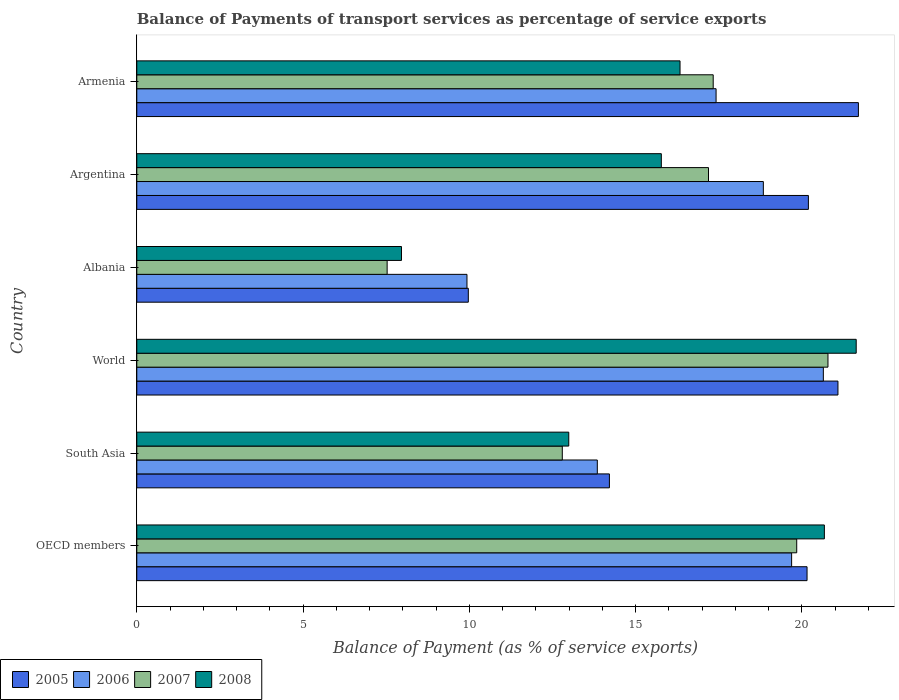How many different coloured bars are there?
Offer a very short reply. 4. How many groups of bars are there?
Give a very brief answer. 6. Are the number of bars on each tick of the Y-axis equal?
Ensure brevity in your answer.  Yes. In how many cases, is the number of bars for a given country not equal to the number of legend labels?
Offer a very short reply. 0. What is the balance of payments of transport services in 2007 in Albania?
Offer a very short reply. 7.53. Across all countries, what is the maximum balance of payments of transport services in 2005?
Your answer should be compact. 21.7. Across all countries, what is the minimum balance of payments of transport services in 2005?
Make the answer very short. 9.97. In which country was the balance of payments of transport services in 2008 maximum?
Your answer should be compact. World. In which country was the balance of payments of transport services in 2005 minimum?
Provide a succinct answer. Albania. What is the total balance of payments of transport services in 2005 in the graph?
Give a very brief answer. 107.33. What is the difference between the balance of payments of transport services in 2005 in Argentina and that in World?
Your answer should be very brief. -0.89. What is the difference between the balance of payments of transport services in 2005 in South Asia and the balance of payments of transport services in 2006 in OECD members?
Your answer should be compact. -5.48. What is the average balance of payments of transport services in 2005 per country?
Offer a very short reply. 17.89. What is the difference between the balance of payments of transport services in 2007 and balance of payments of transport services in 2005 in Armenia?
Keep it short and to the point. -4.37. In how many countries, is the balance of payments of transport services in 2008 greater than 18 %?
Provide a succinct answer. 2. What is the ratio of the balance of payments of transport services in 2008 in Albania to that in South Asia?
Your answer should be very brief. 0.61. Is the difference between the balance of payments of transport services in 2007 in Argentina and World greater than the difference between the balance of payments of transport services in 2005 in Argentina and World?
Make the answer very short. No. What is the difference between the highest and the second highest balance of payments of transport services in 2006?
Offer a terse response. 0.95. What is the difference between the highest and the lowest balance of payments of transport services in 2008?
Your response must be concise. 13.68. Is the sum of the balance of payments of transport services in 2006 in OECD members and South Asia greater than the maximum balance of payments of transport services in 2005 across all countries?
Keep it short and to the point. Yes. What does the 4th bar from the bottom in Armenia represents?
Make the answer very short. 2008. Are all the bars in the graph horizontal?
Your answer should be very brief. Yes. How many countries are there in the graph?
Offer a terse response. 6. What is the difference between two consecutive major ticks on the X-axis?
Ensure brevity in your answer.  5. Where does the legend appear in the graph?
Ensure brevity in your answer.  Bottom left. How many legend labels are there?
Your response must be concise. 4. What is the title of the graph?
Ensure brevity in your answer.  Balance of Payments of transport services as percentage of service exports. Does "2015" appear as one of the legend labels in the graph?
Your answer should be very brief. No. What is the label or title of the X-axis?
Your answer should be compact. Balance of Payment (as % of service exports). What is the Balance of Payment (as % of service exports) of 2005 in OECD members?
Make the answer very short. 20.16. What is the Balance of Payment (as % of service exports) of 2006 in OECD members?
Provide a short and direct response. 19.69. What is the Balance of Payment (as % of service exports) of 2007 in OECD members?
Offer a terse response. 19.85. What is the Balance of Payment (as % of service exports) of 2008 in OECD members?
Offer a very short reply. 20.68. What is the Balance of Payment (as % of service exports) of 2005 in South Asia?
Your answer should be compact. 14.21. What is the Balance of Payment (as % of service exports) in 2006 in South Asia?
Offer a terse response. 13.85. What is the Balance of Payment (as % of service exports) in 2007 in South Asia?
Make the answer very short. 12.8. What is the Balance of Payment (as % of service exports) of 2008 in South Asia?
Ensure brevity in your answer.  12.99. What is the Balance of Payment (as % of service exports) of 2005 in World?
Offer a very short reply. 21.09. What is the Balance of Payment (as % of service exports) of 2006 in World?
Give a very brief answer. 20.65. What is the Balance of Payment (as % of service exports) in 2007 in World?
Offer a terse response. 20.79. What is the Balance of Payment (as % of service exports) of 2008 in World?
Keep it short and to the point. 21.64. What is the Balance of Payment (as % of service exports) in 2005 in Albania?
Give a very brief answer. 9.97. What is the Balance of Payment (as % of service exports) in 2006 in Albania?
Make the answer very short. 9.93. What is the Balance of Payment (as % of service exports) in 2007 in Albania?
Your response must be concise. 7.53. What is the Balance of Payment (as % of service exports) in 2008 in Albania?
Your answer should be very brief. 7.96. What is the Balance of Payment (as % of service exports) in 2005 in Argentina?
Ensure brevity in your answer.  20.2. What is the Balance of Payment (as % of service exports) of 2006 in Argentina?
Ensure brevity in your answer.  18.84. What is the Balance of Payment (as % of service exports) in 2007 in Argentina?
Make the answer very short. 17.19. What is the Balance of Payment (as % of service exports) in 2008 in Argentina?
Provide a succinct answer. 15.78. What is the Balance of Payment (as % of service exports) in 2005 in Armenia?
Make the answer very short. 21.7. What is the Balance of Payment (as % of service exports) in 2006 in Armenia?
Offer a very short reply. 17.42. What is the Balance of Payment (as % of service exports) of 2007 in Armenia?
Give a very brief answer. 17.34. What is the Balance of Payment (as % of service exports) of 2008 in Armenia?
Provide a succinct answer. 16.34. Across all countries, what is the maximum Balance of Payment (as % of service exports) in 2005?
Your answer should be very brief. 21.7. Across all countries, what is the maximum Balance of Payment (as % of service exports) of 2006?
Ensure brevity in your answer.  20.65. Across all countries, what is the maximum Balance of Payment (as % of service exports) in 2007?
Provide a succinct answer. 20.79. Across all countries, what is the maximum Balance of Payment (as % of service exports) of 2008?
Give a very brief answer. 21.64. Across all countries, what is the minimum Balance of Payment (as % of service exports) of 2005?
Keep it short and to the point. 9.97. Across all countries, what is the minimum Balance of Payment (as % of service exports) in 2006?
Give a very brief answer. 9.93. Across all countries, what is the minimum Balance of Payment (as % of service exports) of 2007?
Give a very brief answer. 7.53. Across all countries, what is the minimum Balance of Payment (as % of service exports) in 2008?
Offer a very short reply. 7.96. What is the total Balance of Payment (as % of service exports) of 2005 in the graph?
Your answer should be compact. 107.33. What is the total Balance of Payment (as % of service exports) of 2006 in the graph?
Keep it short and to the point. 100.39. What is the total Balance of Payment (as % of service exports) in 2007 in the graph?
Offer a terse response. 95.49. What is the total Balance of Payment (as % of service exports) of 2008 in the graph?
Your answer should be compact. 95.38. What is the difference between the Balance of Payment (as % of service exports) of 2005 in OECD members and that in South Asia?
Make the answer very short. 5.94. What is the difference between the Balance of Payment (as % of service exports) of 2006 in OECD members and that in South Asia?
Offer a very short reply. 5.84. What is the difference between the Balance of Payment (as % of service exports) of 2007 in OECD members and that in South Asia?
Make the answer very short. 7.05. What is the difference between the Balance of Payment (as % of service exports) in 2008 in OECD members and that in South Asia?
Offer a very short reply. 7.69. What is the difference between the Balance of Payment (as % of service exports) in 2005 in OECD members and that in World?
Your answer should be very brief. -0.93. What is the difference between the Balance of Payment (as % of service exports) in 2006 in OECD members and that in World?
Keep it short and to the point. -0.95. What is the difference between the Balance of Payment (as % of service exports) in 2007 in OECD members and that in World?
Your answer should be very brief. -0.94. What is the difference between the Balance of Payment (as % of service exports) in 2008 in OECD members and that in World?
Offer a very short reply. -0.96. What is the difference between the Balance of Payment (as % of service exports) of 2005 in OECD members and that in Albania?
Make the answer very short. 10.19. What is the difference between the Balance of Payment (as % of service exports) of 2006 in OECD members and that in Albania?
Ensure brevity in your answer.  9.76. What is the difference between the Balance of Payment (as % of service exports) in 2007 in OECD members and that in Albania?
Give a very brief answer. 12.32. What is the difference between the Balance of Payment (as % of service exports) in 2008 in OECD members and that in Albania?
Your answer should be compact. 12.72. What is the difference between the Balance of Payment (as % of service exports) in 2005 in OECD members and that in Argentina?
Ensure brevity in your answer.  -0.04. What is the difference between the Balance of Payment (as % of service exports) in 2006 in OECD members and that in Argentina?
Keep it short and to the point. 0.85. What is the difference between the Balance of Payment (as % of service exports) in 2007 in OECD members and that in Argentina?
Your response must be concise. 2.65. What is the difference between the Balance of Payment (as % of service exports) of 2008 in OECD members and that in Argentina?
Offer a very short reply. 4.9. What is the difference between the Balance of Payment (as % of service exports) in 2005 in OECD members and that in Armenia?
Give a very brief answer. -1.54. What is the difference between the Balance of Payment (as % of service exports) of 2006 in OECD members and that in Armenia?
Your response must be concise. 2.27. What is the difference between the Balance of Payment (as % of service exports) in 2007 in OECD members and that in Armenia?
Provide a succinct answer. 2.51. What is the difference between the Balance of Payment (as % of service exports) of 2008 in OECD members and that in Armenia?
Offer a very short reply. 4.34. What is the difference between the Balance of Payment (as % of service exports) of 2005 in South Asia and that in World?
Give a very brief answer. -6.87. What is the difference between the Balance of Payment (as % of service exports) of 2006 in South Asia and that in World?
Offer a terse response. -6.8. What is the difference between the Balance of Payment (as % of service exports) in 2007 in South Asia and that in World?
Make the answer very short. -7.99. What is the difference between the Balance of Payment (as % of service exports) in 2008 in South Asia and that in World?
Give a very brief answer. -8.64. What is the difference between the Balance of Payment (as % of service exports) of 2005 in South Asia and that in Albania?
Provide a short and direct response. 4.24. What is the difference between the Balance of Payment (as % of service exports) in 2006 in South Asia and that in Albania?
Your answer should be very brief. 3.92. What is the difference between the Balance of Payment (as % of service exports) in 2007 in South Asia and that in Albania?
Your answer should be compact. 5.27. What is the difference between the Balance of Payment (as % of service exports) in 2008 in South Asia and that in Albania?
Provide a succinct answer. 5.03. What is the difference between the Balance of Payment (as % of service exports) of 2005 in South Asia and that in Argentina?
Your response must be concise. -5.98. What is the difference between the Balance of Payment (as % of service exports) of 2006 in South Asia and that in Argentina?
Ensure brevity in your answer.  -4.99. What is the difference between the Balance of Payment (as % of service exports) of 2007 in South Asia and that in Argentina?
Ensure brevity in your answer.  -4.4. What is the difference between the Balance of Payment (as % of service exports) of 2008 in South Asia and that in Argentina?
Ensure brevity in your answer.  -2.78. What is the difference between the Balance of Payment (as % of service exports) of 2005 in South Asia and that in Armenia?
Your response must be concise. -7.49. What is the difference between the Balance of Payment (as % of service exports) in 2006 in South Asia and that in Armenia?
Ensure brevity in your answer.  -3.57. What is the difference between the Balance of Payment (as % of service exports) in 2007 in South Asia and that in Armenia?
Keep it short and to the point. -4.54. What is the difference between the Balance of Payment (as % of service exports) of 2008 in South Asia and that in Armenia?
Your answer should be very brief. -3.35. What is the difference between the Balance of Payment (as % of service exports) in 2005 in World and that in Albania?
Your answer should be compact. 11.12. What is the difference between the Balance of Payment (as % of service exports) of 2006 in World and that in Albania?
Offer a terse response. 10.72. What is the difference between the Balance of Payment (as % of service exports) of 2007 in World and that in Albania?
Provide a succinct answer. 13.26. What is the difference between the Balance of Payment (as % of service exports) in 2008 in World and that in Albania?
Your answer should be compact. 13.68. What is the difference between the Balance of Payment (as % of service exports) of 2005 in World and that in Argentina?
Keep it short and to the point. 0.89. What is the difference between the Balance of Payment (as % of service exports) in 2006 in World and that in Argentina?
Give a very brief answer. 1.8. What is the difference between the Balance of Payment (as % of service exports) in 2007 in World and that in Argentina?
Provide a short and direct response. 3.59. What is the difference between the Balance of Payment (as % of service exports) of 2008 in World and that in Argentina?
Offer a terse response. 5.86. What is the difference between the Balance of Payment (as % of service exports) in 2005 in World and that in Armenia?
Your response must be concise. -0.62. What is the difference between the Balance of Payment (as % of service exports) of 2006 in World and that in Armenia?
Your answer should be compact. 3.23. What is the difference between the Balance of Payment (as % of service exports) of 2007 in World and that in Armenia?
Provide a short and direct response. 3.45. What is the difference between the Balance of Payment (as % of service exports) in 2008 in World and that in Armenia?
Give a very brief answer. 5.3. What is the difference between the Balance of Payment (as % of service exports) of 2005 in Albania and that in Argentina?
Provide a short and direct response. -10.23. What is the difference between the Balance of Payment (as % of service exports) in 2006 in Albania and that in Argentina?
Ensure brevity in your answer.  -8.91. What is the difference between the Balance of Payment (as % of service exports) of 2007 in Albania and that in Argentina?
Provide a succinct answer. -9.67. What is the difference between the Balance of Payment (as % of service exports) of 2008 in Albania and that in Argentina?
Ensure brevity in your answer.  -7.81. What is the difference between the Balance of Payment (as % of service exports) in 2005 in Albania and that in Armenia?
Offer a terse response. -11.73. What is the difference between the Balance of Payment (as % of service exports) in 2006 in Albania and that in Armenia?
Give a very brief answer. -7.49. What is the difference between the Balance of Payment (as % of service exports) in 2007 in Albania and that in Armenia?
Keep it short and to the point. -9.81. What is the difference between the Balance of Payment (as % of service exports) in 2008 in Albania and that in Armenia?
Offer a very short reply. -8.38. What is the difference between the Balance of Payment (as % of service exports) in 2005 in Argentina and that in Armenia?
Offer a very short reply. -1.5. What is the difference between the Balance of Payment (as % of service exports) in 2006 in Argentina and that in Armenia?
Offer a terse response. 1.42. What is the difference between the Balance of Payment (as % of service exports) in 2007 in Argentina and that in Armenia?
Ensure brevity in your answer.  -0.14. What is the difference between the Balance of Payment (as % of service exports) of 2008 in Argentina and that in Armenia?
Give a very brief answer. -0.56. What is the difference between the Balance of Payment (as % of service exports) in 2005 in OECD members and the Balance of Payment (as % of service exports) in 2006 in South Asia?
Make the answer very short. 6.31. What is the difference between the Balance of Payment (as % of service exports) in 2005 in OECD members and the Balance of Payment (as % of service exports) in 2007 in South Asia?
Offer a very short reply. 7.36. What is the difference between the Balance of Payment (as % of service exports) of 2005 in OECD members and the Balance of Payment (as % of service exports) of 2008 in South Asia?
Keep it short and to the point. 7.17. What is the difference between the Balance of Payment (as % of service exports) in 2006 in OECD members and the Balance of Payment (as % of service exports) in 2007 in South Asia?
Ensure brevity in your answer.  6.9. What is the difference between the Balance of Payment (as % of service exports) of 2006 in OECD members and the Balance of Payment (as % of service exports) of 2008 in South Asia?
Make the answer very short. 6.7. What is the difference between the Balance of Payment (as % of service exports) of 2007 in OECD members and the Balance of Payment (as % of service exports) of 2008 in South Asia?
Your answer should be compact. 6.86. What is the difference between the Balance of Payment (as % of service exports) in 2005 in OECD members and the Balance of Payment (as % of service exports) in 2006 in World?
Provide a short and direct response. -0.49. What is the difference between the Balance of Payment (as % of service exports) of 2005 in OECD members and the Balance of Payment (as % of service exports) of 2007 in World?
Keep it short and to the point. -0.63. What is the difference between the Balance of Payment (as % of service exports) in 2005 in OECD members and the Balance of Payment (as % of service exports) in 2008 in World?
Provide a short and direct response. -1.48. What is the difference between the Balance of Payment (as % of service exports) in 2006 in OECD members and the Balance of Payment (as % of service exports) in 2007 in World?
Provide a short and direct response. -1.09. What is the difference between the Balance of Payment (as % of service exports) in 2006 in OECD members and the Balance of Payment (as % of service exports) in 2008 in World?
Your answer should be compact. -1.94. What is the difference between the Balance of Payment (as % of service exports) in 2007 in OECD members and the Balance of Payment (as % of service exports) in 2008 in World?
Offer a terse response. -1.79. What is the difference between the Balance of Payment (as % of service exports) of 2005 in OECD members and the Balance of Payment (as % of service exports) of 2006 in Albania?
Your response must be concise. 10.23. What is the difference between the Balance of Payment (as % of service exports) in 2005 in OECD members and the Balance of Payment (as % of service exports) in 2007 in Albania?
Offer a terse response. 12.63. What is the difference between the Balance of Payment (as % of service exports) of 2005 in OECD members and the Balance of Payment (as % of service exports) of 2008 in Albania?
Your answer should be very brief. 12.2. What is the difference between the Balance of Payment (as % of service exports) of 2006 in OECD members and the Balance of Payment (as % of service exports) of 2007 in Albania?
Offer a terse response. 12.17. What is the difference between the Balance of Payment (as % of service exports) in 2006 in OECD members and the Balance of Payment (as % of service exports) in 2008 in Albania?
Make the answer very short. 11.73. What is the difference between the Balance of Payment (as % of service exports) of 2007 in OECD members and the Balance of Payment (as % of service exports) of 2008 in Albania?
Provide a succinct answer. 11.89. What is the difference between the Balance of Payment (as % of service exports) in 2005 in OECD members and the Balance of Payment (as % of service exports) in 2006 in Argentina?
Give a very brief answer. 1.31. What is the difference between the Balance of Payment (as % of service exports) of 2005 in OECD members and the Balance of Payment (as % of service exports) of 2007 in Argentina?
Offer a very short reply. 2.96. What is the difference between the Balance of Payment (as % of service exports) of 2005 in OECD members and the Balance of Payment (as % of service exports) of 2008 in Argentina?
Your answer should be compact. 4.38. What is the difference between the Balance of Payment (as % of service exports) in 2006 in OECD members and the Balance of Payment (as % of service exports) in 2007 in Argentina?
Your response must be concise. 2.5. What is the difference between the Balance of Payment (as % of service exports) in 2006 in OECD members and the Balance of Payment (as % of service exports) in 2008 in Argentina?
Provide a short and direct response. 3.92. What is the difference between the Balance of Payment (as % of service exports) of 2007 in OECD members and the Balance of Payment (as % of service exports) of 2008 in Argentina?
Make the answer very short. 4.07. What is the difference between the Balance of Payment (as % of service exports) in 2005 in OECD members and the Balance of Payment (as % of service exports) in 2006 in Armenia?
Offer a terse response. 2.74. What is the difference between the Balance of Payment (as % of service exports) of 2005 in OECD members and the Balance of Payment (as % of service exports) of 2007 in Armenia?
Your answer should be very brief. 2.82. What is the difference between the Balance of Payment (as % of service exports) in 2005 in OECD members and the Balance of Payment (as % of service exports) in 2008 in Armenia?
Your response must be concise. 3.82. What is the difference between the Balance of Payment (as % of service exports) of 2006 in OECD members and the Balance of Payment (as % of service exports) of 2007 in Armenia?
Ensure brevity in your answer.  2.36. What is the difference between the Balance of Payment (as % of service exports) of 2006 in OECD members and the Balance of Payment (as % of service exports) of 2008 in Armenia?
Offer a very short reply. 3.36. What is the difference between the Balance of Payment (as % of service exports) of 2007 in OECD members and the Balance of Payment (as % of service exports) of 2008 in Armenia?
Provide a succinct answer. 3.51. What is the difference between the Balance of Payment (as % of service exports) of 2005 in South Asia and the Balance of Payment (as % of service exports) of 2006 in World?
Provide a short and direct response. -6.43. What is the difference between the Balance of Payment (as % of service exports) of 2005 in South Asia and the Balance of Payment (as % of service exports) of 2007 in World?
Your response must be concise. -6.57. What is the difference between the Balance of Payment (as % of service exports) in 2005 in South Asia and the Balance of Payment (as % of service exports) in 2008 in World?
Your answer should be very brief. -7.42. What is the difference between the Balance of Payment (as % of service exports) of 2006 in South Asia and the Balance of Payment (as % of service exports) of 2007 in World?
Your answer should be compact. -6.94. What is the difference between the Balance of Payment (as % of service exports) of 2006 in South Asia and the Balance of Payment (as % of service exports) of 2008 in World?
Provide a succinct answer. -7.79. What is the difference between the Balance of Payment (as % of service exports) of 2007 in South Asia and the Balance of Payment (as % of service exports) of 2008 in World?
Give a very brief answer. -8.84. What is the difference between the Balance of Payment (as % of service exports) of 2005 in South Asia and the Balance of Payment (as % of service exports) of 2006 in Albania?
Your response must be concise. 4.28. What is the difference between the Balance of Payment (as % of service exports) of 2005 in South Asia and the Balance of Payment (as % of service exports) of 2007 in Albania?
Offer a very short reply. 6.68. What is the difference between the Balance of Payment (as % of service exports) of 2005 in South Asia and the Balance of Payment (as % of service exports) of 2008 in Albania?
Your answer should be very brief. 6.25. What is the difference between the Balance of Payment (as % of service exports) in 2006 in South Asia and the Balance of Payment (as % of service exports) in 2007 in Albania?
Make the answer very short. 6.32. What is the difference between the Balance of Payment (as % of service exports) in 2006 in South Asia and the Balance of Payment (as % of service exports) in 2008 in Albania?
Provide a succinct answer. 5.89. What is the difference between the Balance of Payment (as % of service exports) in 2007 in South Asia and the Balance of Payment (as % of service exports) in 2008 in Albania?
Make the answer very short. 4.84. What is the difference between the Balance of Payment (as % of service exports) of 2005 in South Asia and the Balance of Payment (as % of service exports) of 2006 in Argentina?
Provide a short and direct response. -4.63. What is the difference between the Balance of Payment (as % of service exports) in 2005 in South Asia and the Balance of Payment (as % of service exports) in 2007 in Argentina?
Offer a very short reply. -2.98. What is the difference between the Balance of Payment (as % of service exports) of 2005 in South Asia and the Balance of Payment (as % of service exports) of 2008 in Argentina?
Offer a terse response. -1.56. What is the difference between the Balance of Payment (as % of service exports) of 2006 in South Asia and the Balance of Payment (as % of service exports) of 2007 in Argentina?
Provide a succinct answer. -3.34. What is the difference between the Balance of Payment (as % of service exports) of 2006 in South Asia and the Balance of Payment (as % of service exports) of 2008 in Argentina?
Provide a short and direct response. -1.93. What is the difference between the Balance of Payment (as % of service exports) of 2007 in South Asia and the Balance of Payment (as % of service exports) of 2008 in Argentina?
Keep it short and to the point. -2.98. What is the difference between the Balance of Payment (as % of service exports) of 2005 in South Asia and the Balance of Payment (as % of service exports) of 2006 in Armenia?
Make the answer very short. -3.21. What is the difference between the Balance of Payment (as % of service exports) in 2005 in South Asia and the Balance of Payment (as % of service exports) in 2007 in Armenia?
Give a very brief answer. -3.12. What is the difference between the Balance of Payment (as % of service exports) in 2005 in South Asia and the Balance of Payment (as % of service exports) in 2008 in Armenia?
Make the answer very short. -2.12. What is the difference between the Balance of Payment (as % of service exports) of 2006 in South Asia and the Balance of Payment (as % of service exports) of 2007 in Armenia?
Your answer should be compact. -3.49. What is the difference between the Balance of Payment (as % of service exports) of 2006 in South Asia and the Balance of Payment (as % of service exports) of 2008 in Armenia?
Your answer should be compact. -2.49. What is the difference between the Balance of Payment (as % of service exports) of 2007 in South Asia and the Balance of Payment (as % of service exports) of 2008 in Armenia?
Give a very brief answer. -3.54. What is the difference between the Balance of Payment (as % of service exports) of 2005 in World and the Balance of Payment (as % of service exports) of 2006 in Albania?
Give a very brief answer. 11.16. What is the difference between the Balance of Payment (as % of service exports) in 2005 in World and the Balance of Payment (as % of service exports) in 2007 in Albania?
Your answer should be compact. 13.56. What is the difference between the Balance of Payment (as % of service exports) of 2005 in World and the Balance of Payment (as % of service exports) of 2008 in Albania?
Provide a succinct answer. 13.13. What is the difference between the Balance of Payment (as % of service exports) of 2006 in World and the Balance of Payment (as % of service exports) of 2007 in Albania?
Ensure brevity in your answer.  13.12. What is the difference between the Balance of Payment (as % of service exports) in 2006 in World and the Balance of Payment (as % of service exports) in 2008 in Albania?
Make the answer very short. 12.69. What is the difference between the Balance of Payment (as % of service exports) of 2007 in World and the Balance of Payment (as % of service exports) of 2008 in Albania?
Offer a very short reply. 12.83. What is the difference between the Balance of Payment (as % of service exports) in 2005 in World and the Balance of Payment (as % of service exports) in 2006 in Argentina?
Your response must be concise. 2.24. What is the difference between the Balance of Payment (as % of service exports) in 2005 in World and the Balance of Payment (as % of service exports) in 2007 in Argentina?
Provide a succinct answer. 3.89. What is the difference between the Balance of Payment (as % of service exports) in 2005 in World and the Balance of Payment (as % of service exports) in 2008 in Argentina?
Your answer should be compact. 5.31. What is the difference between the Balance of Payment (as % of service exports) in 2006 in World and the Balance of Payment (as % of service exports) in 2007 in Argentina?
Offer a very short reply. 3.45. What is the difference between the Balance of Payment (as % of service exports) of 2006 in World and the Balance of Payment (as % of service exports) of 2008 in Argentina?
Offer a terse response. 4.87. What is the difference between the Balance of Payment (as % of service exports) of 2007 in World and the Balance of Payment (as % of service exports) of 2008 in Argentina?
Your answer should be compact. 5.01. What is the difference between the Balance of Payment (as % of service exports) of 2005 in World and the Balance of Payment (as % of service exports) of 2006 in Armenia?
Your answer should be compact. 3.67. What is the difference between the Balance of Payment (as % of service exports) in 2005 in World and the Balance of Payment (as % of service exports) in 2007 in Armenia?
Keep it short and to the point. 3.75. What is the difference between the Balance of Payment (as % of service exports) in 2005 in World and the Balance of Payment (as % of service exports) in 2008 in Armenia?
Offer a terse response. 4.75. What is the difference between the Balance of Payment (as % of service exports) of 2006 in World and the Balance of Payment (as % of service exports) of 2007 in Armenia?
Your response must be concise. 3.31. What is the difference between the Balance of Payment (as % of service exports) of 2006 in World and the Balance of Payment (as % of service exports) of 2008 in Armenia?
Ensure brevity in your answer.  4.31. What is the difference between the Balance of Payment (as % of service exports) of 2007 in World and the Balance of Payment (as % of service exports) of 2008 in Armenia?
Give a very brief answer. 4.45. What is the difference between the Balance of Payment (as % of service exports) of 2005 in Albania and the Balance of Payment (as % of service exports) of 2006 in Argentina?
Offer a terse response. -8.87. What is the difference between the Balance of Payment (as % of service exports) in 2005 in Albania and the Balance of Payment (as % of service exports) in 2007 in Argentina?
Offer a very short reply. -7.22. What is the difference between the Balance of Payment (as % of service exports) in 2005 in Albania and the Balance of Payment (as % of service exports) in 2008 in Argentina?
Keep it short and to the point. -5.8. What is the difference between the Balance of Payment (as % of service exports) of 2006 in Albania and the Balance of Payment (as % of service exports) of 2007 in Argentina?
Provide a short and direct response. -7.26. What is the difference between the Balance of Payment (as % of service exports) of 2006 in Albania and the Balance of Payment (as % of service exports) of 2008 in Argentina?
Make the answer very short. -5.85. What is the difference between the Balance of Payment (as % of service exports) in 2007 in Albania and the Balance of Payment (as % of service exports) in 2008 in Argentina?
Ensure brevity in your answer.  -8.25. What is the difference between the Balance of Payment (as % of service exports) of 2005 in Albania and the Balance of Payment (as % of service exports) of 2006 in Armenia?
Offer a terse response. -7.45. What is the difference between the Balance of Payment (as % of service exports) of 2005 in Albania and the Balance of Payment (as % of service exports) of 2007 in Armenia?
Make the answer very short. -7.37. What is the difference between the Balance of Payment (as % of service exports) of 2005 in Albania and the Balance of Payment (as % of service exports) of 2008 in Armenia?
Provide a succinct answer. -6.37. What is the difference between the Balance of Payment (as % of service exports) in 2006 in Albania and the Balance of Payment (as % of service exports) in 2007 in Armenia?
Provide a short and direct response. -7.41. What is the difference between the Balance of Payment (as % of service exports) of 2006 in Albania and the Balance of Payment (as % of service exports) of 2008 in Armenia?
Make the answer very short. -6.41. What is the difference between the Balance of Payment (as % of service exports) in 2007 in Albania and the Balance of Payment (as % of service exports) in 2008 in Armenia?
Your answer should be compact. -8.81. What is the difference between the Balance of Payment (as % of service exports) of 2005 in Argentina and the Balance of Payment (as % of service exports) of 2006 in Armenia?
Offer a terse response. 2.78. What is the difference between the Balance of Payment (as % of service exports) in 2005 in Argentina and the Balance of Payment (as % of service exports) in 2007 in Armenia?
Make the answer very short. 2.86. What is the difference between the Balance of Payment (as % of service exports) in 2005 in Argentina and the Balance of Payment (as % of service exports) in 2008 in Armenia?
Your answer should be compact. 3.86. What is the difference between the Balance of Payment (as % of service exports) of 2006 in Argentina and the Balance of Payment (as % of service exports) of 2007 in Armenia?
Offer a very short reply. 1.51. What is the difference between the Balance of Payment (as % of service exports) in 2006 in Argentina and the Balance of Payment (as % of service exports) in 2008 in Armenia?
Your response must be concise. 2.51. What is the difference between the Balance of Payment (as % of service exports) in 2007 in Argentina and the Balance of Payment (as % of service exports) in 2008 in Armenia?
Offer a terse response. 0.86. What is the average Balance of Payment (as % of service exports) of 2005 per country?
Keep it short and to the point. 17.89. What is the average Balance of Payment (as % of service exports) in 2006 per country?
Your answer should be very brief. 16.73. What is the average Balance of Payment (as % of service exports) of 2007 per country?
Make the answer very short. 15.91. What is the average Balance of Payment (as % of service exports) in 2008 per country?
Give a very brief answer. 15.9. What is the difference between the Balance of Payment (as % of service exports) of 2005 and Balance of Payment (as % of service exports) of 2006 in OECD members?
Your response must be concise. 0.46. What is the difference between the Balance of Payment (as % of service exports) in 2005 and Balance of Payment (as % of service exports) in 2007 in OECD members?
Offer a very short reply. 0.31. What is the difference between the Balance of Payment (as % of service exports) in 2005 and Balance of Payment (as % of service exports) in 2008 in OECD members?
Your answer should be compact. -0.52. What is the difference between the Balance of Payment (as % of service exports) of 2006 and Balance of Payment (as % of service exports) of 2007 in OECD members?
Your answer should be very brief. -0.15. What is the difference between the Balance of Payment (as % of service exports) of 2006 and Balance of Payment (as % of service exports) of 2008 in OECD members?
Provide a succinct answer. -0.98. What is the difference between the Balance of Payment (as % of service exports) of 2007 and Balance of Payment (as % of service exports) of 2008 in OECD members?
Provide a short and direct response. -0.83. What is the difference between the Balance of Payment (as % of service exports) in 2005 and Balance of Payment (as % of service exports) in 2006 in South Asia?
Your answer should be compact. 0.36. What is the difference between the Balance of Payment (as % of service exports) of 2005 and Balance of Payment (as % of service exports) of 2007 in South Asia?
Your answer should be very brief. 1.42. What is the difference between the Balance of Payment (as % of service exports) in 2005 and Balance of Payment (as % of service exports) in 2008 in South Asia?
Provide a succinct answer. 1.22. What is the difference between the Balance of Payment (as % of service exports) in 2006 and Balance of Payment (as % of service exports) in 2007 in South Asia?
Keep it short and to the point. 1.05. What is the difference between the Balance of Payment (as % of service exports) in 2006 and Balance of Payment (as % of service exports) in 2008 in South Asia?
Offer a terse response. 0.86. What is the difference between the Balance of Payment (as % of service exports) in 2007 and Balance of Payment (as % of service exports) in 2008 in South Asia?
Ensure brevity in your answer.  -0.19. What is the difference between the Balance of Payment (as % of service exports) of 2005 and Balance of Payment (as % of service exports) of 2006 in World?
Ensure brevity in your answer.  0.44. What is the difference between the Balance of Payment (as % of service exports) of 2005 and Balance of Payment (as % of service exports) of 2007 in World?
Ensure brevity in your answer.  0.3. What is the difference between the Balance of Payment (as % of service exports) of 2005 and Balance of Payment (as % of service exports) of 2008 in World?
Make the answer very short. -0.55. What is the difference between the Balance of Payment (as % of service exports) in 2006 and Balance of Payment (as % of service exports) in 2007 in World?
Provide a succinct answer. -0.14. What is the difference between the Balance of Payment (as % of service exports) of 2006 and Balance of Payment (as % of service exports) of 2008 in World?
Offer a terse response. -0.99. What is the difference between the Balance of Payment (as % of service exports) of 2007 and Balance of Payment (as % of service exports) of 2008 in World?
Keep it short and to the point. -0.85. What is the difference between the Balance of Payment (as % of service exports) in 2005 and Balance of Payment (as % of service exports) in 2006 in Albania?
Your answer should be compact. 0.04. What is the difference between the Balance of Payment (as % of service exports) in 2005 and Balance of Payment (as % of service exports) in 2007 in Albania?
Your answer should be compact. 2.44. What is the difference between the Balance of Payment (as % of service exports) of 2005 and Balance of Payment (as % of service exports) of 2008 in Albania?
Your answer should be very brief. 2.01. What is the difference between the Balance of Payment (as % of service exports) in 2006 and Balance of Payment (as % of service exports) in 2007 in Albania?
Provide a succinct answer. 2.4. What is the difference between the Balance of Payment (as % of service exports) of 2006 and Balance of Payment (as % of service exports) of 2008 in Albania?
Your answer should be very brief. 1.97. What is the difference between the Balance of Payment (as % of service exports) in 2007 and Balance of Payment (as % of service exports) in 2008 in Albania?
Offer a terse response. -0.43. What is the difference between the Balance of Payment (as % of service exports) of 2005 and Balance of Payment (as % of service exports) of 2006 in Argentina?
Your response must be concise. 1.35. What is the difference between the Balance of Payment (as % of service exports) in 2005 and Balance of Payment (as % of service exports) in 2007 in Argentina?
Ensure brevity in your answer.  3. What is the difference between the Balance of Payment (as % of service exports) of 2005 and Balance of Payment (as % of service exports) of 2008 in Argentina?
Keep it short and to the point. 4.42. What is the difference between the Balance of Payment (as % of service exports) in 2006 and Balance of Payment (as % of service exports) in 2007 in Argentina?
Your answer should be compact. 1.65. What is the difference between the Balance of Payment (as % of service exports) of 2006 and Balance of Payment (as % of service exports) of 2008 in Argentina?
Give a very brief answer. 3.07. What is the difference between the Balance of Payment (as % of service exports) in 2007 and Balance of Payment (as % of service exports) in 2008 in Argentina?
Offer a terse response. 1.42. What is the difference between the Balance of Payment (as % of service exports) in 2005 and Balance of Payment (as % of service exports) in 2006 in Armenia?
Provide a succinct answer. 4.28. What is the difference between the Balance of Payment (as % of service exports) of 2005 and Balance of Payment (as % of service exports) of 2007 in Armenia?
Provide a succinct answer. 4.37. What is the difference between the Balance of Payment (as % of service exports) of 2005 and Balance of Payment (as % of service exports) of 2008 in Armenia?
Give a very brief answer. 5.36. What is the difference between the Balance of Payment (as % of service exports) in 2006 and Balance of Payment (as % of service exports) in 2007 in Armenia?
Provide a short and direct response. 0.09. What is the difference between the Balance of Payment (as % of service exports) in 2006 and Balance of Payment (as % of service exports) in 2008 in Armenia?
Your response must be concise. 1.08. What is the difference between the Balance of Payment (as % of service exports) in 2007 and Balance of Payment (as % of service exports) in 2008 in Armenia?
Give a very brief answer. 1. What is the ratio of the Balance of Payment (as % of service exports) in 2005 in OECD members to that in South Asia?
Provide a short and direct response. 1.42. What is the ratio of the Balance of Payment (as % of service exports) of 2006 in OECD members to that in South Asia?
Offer a very short reply. 1.42. What is the ratio of the Balance of Payment (as % of service exports) of 2007 in OECD members to that in South Asia?
Provide a succinct answer. 1.55. What is the ratio of the Balance of Payment (as % of service exports) in 2008 in OECD members to that in South Asia?
Provide a succinct answer. 1.59. What is the ratio of the Balance of Payment (as % of service exports) in 2005 in OECD members to that in World?
Provide a succinct answer. 0.96. What is the ratio of the Balance of Payment (as % of service exports) in 2006 in OECD members to that in World?
Give a very brief answer. 0.95. What is the ratio of the Balance of Payment (as % of service exports) of 2007 in OECD members to that in World?
Your answer should be compact. 0.95. What is the ratio of the Balance of Payment (as % of service exports) of 2008 in OECD members to that in World?
Provide a short and direct response. 0.96. What is the ratio of the Balance of Payment (as % of service exports) of 2005 in OECD members to that in Albania?
Your answer should be compact. 2.02. What is the ratio of the Balance of Payment (as % of service exports) in 2006 in OECD members to that in Albania?
Provide a succinct answer. 1.98. What is the ratio of the Balance of Payment (as % of service exports) of 2007 in OECD members to that in Albania?
Your answer should be compact. 2.64. What is the ratio of the Balance of Payment (as % of service exports) of 2008 in OECD members to that in Albania?
Offer a very short reply. 2.6. What is the ratio of the Balance of Payment (as % of service exports) in 2005 in OECD members to that in Argentina?
Provide a succinct answer. 1. What is the ratio of the Balance of Payment (as % of service exports) in 2006 in OECD members to that in Argentina?
Your answer should be very brief. 1.05. What is the ratio of the Balance of Payment (as % of service exports) in 2007 in OECD members to that in Argentina?
Your answer should be very brief. 1.15. What is the ratio of the Balance of Payment (as % of service exports) of 2008 in OECD members to that in Argentina?
Ensure brevity in your answer.  1.31. What is the ratio of the Balance of Payment (as % of service exports) in 2005 in OECD members to that in Armenia?
Make the answer very short. 0.93. What is the ratio of the Balance of Payment (as % of service exports) in 2006 in OECD members to that in Armenia?
Provide a succinct answer. 1.13. What is the ratio of the Balance of Payment (as % of service exports) in 2007 in OECD members to that in Armenia?
Ensure brevity in your answer.  1.14. What is the ratio of the Balance of Payment (as % of service exports) of 2008 in OECD members to that in Armenia?
Make the answer very short. 1.27. What is the ratio of the Balance of Payment (as % of service exports) of 2005 in South Asia to that in World?
Make the answer very short. 0.67. What is the ratio of the Balance of Payment (as % of service exports) of 2006 in South Asia to that in World?
Offer a very short reply. 0.67. What is the ratio of the Balance of Payment (as % of service exports) of 2007 in South Asia to that in World?
Your answer should be compact. 0.62. What is the ratio of the Balance of Payment (as % of service exports) in 2008 in South Asia to that in World?
Provide a short and direct response. 0.6. What is the ratio of the Balance of Payment (as % of service exports) of 2005 in South Asia to that in Albania?
Make the answer very short. 1.43. What is the ratio of the Balance of Payment (as % of service exports) in 2006 in South Asia to that in Albania?
Offer a terse response. 1.39. What is the ratio of the Balance of Payment (as % of service exports) in 2007 in South Asia to that in Albania?
Your answer should be compact. 1.7. What is the ratio of the Balance of Payment (as % of service exports) in 2008 in South Asia to that in Albania?
Your answer should be very brief. 1.63. What is the ratio of the Balance of Payment (as % of service exports) of 2005 in South Asia to that in Argentina?
Ensure brevity in your answer.  0.7. What is the ratio of the Balance of Payment (as % of service exports) in 2006 in South Asia to that in Argentina?
Give a very brief answer. 0.73. What is the ratio of the Balance of Payment (as % of service exports) in 2007 in South Asia to that in Argentina?
Give a very brief answer. 0.74. What is the ratio of the Balance of Payment (as % of service exports) in 2008 in South Asia to that in Argentina?
Provide a short and direct response. 0.82. What is the ratio of the Balance of Payment (as % of service exports) of 2005 in South Asia to that in Armenia?
Your answer should be compact. 0.65. What is the ratio of the Balance of Payment (as % of service exports) in 2006 in South Asia to that in Armenia?
Offer a very short reply. 0.8. What is the ratio of the Balance of Payment (as % of service exports) of 2007 in South Asia to that in Armenia?
Make the answer very short. 0.74. What is the ratio of the Balance of Payment (as % of service exports) in 2008 in South Asia to that in Armenia?
Make the answer very short. 0.8. What is the ratio of the Balance of Payment (as % of service exports) in 2005 in World to that in Albania?
Your answer should be compact. 2.12. What is the ratio of the Balance of Payment (as % of service exports) of 2006 in World to that in Albania?
Provide a succinct answer. 2.08. What is the ratio of the Balance of Payment (as % of service exports) in 2007 in World to that in Albania?
Your answer should be very brief. 2.76. What is the ratio of the Balance of Payment (as % of service exports) in 2008 in World to that in Albania?
Keep it short and to the point. 2.72. What is the ratio of the Balance of Payment (as % of service exports) of 2005 in World to that in Argentina?
Provide a succinct answer. 1.04. What is the ratio of the Balance of Payment (as % of service exports) of 2006 in World to that in Argentina?
Your answer should be compact. 1.1. What is the ratio of the Balance of Payment (as % of service exports) in 2007 in World to that in Argentina?
Provide a succinct answer. 1.21. What is the ratio of the Balance of Payment (as % of service exports) in 2008 in World to that in Argentina?
Your answer should be compact. 1.37. What is the ratio of the Balance of Payment (as % of service exports) of 2005 in World to that in Armenia?
Ensure brevity in your answer.  0.97. What is the ratio of the Balance of Payment (as % of service exports) in 2006 in World to that in Armenia?
Your response must be concise. 1.19. What is the ratio of the Balance of Payment (as % of service exports) in 2007 in World to that in Armenia?
Provide a succinct answer. 1.2. What is the ratio of the Balance of Payment (as % of service exports) in 2008 in World to that in Armenia?
Keep it short and to the point. 1.32. What is the ratio of the Balance of Payment (as % of service exports) in 2005 in Albania to that in Argentina?
Offer a terse response. 0.49. What is the ratio of the Balance of Payment (as % of service exports) in 2006 in Albania to that in Argentina?
Your answer should be compact. 0.53. What is the ratio of the Balance of Payment (as % of service exports) in 2007 in Albania to that in Argentina?
Your response must be concise. 0.44. What is the ratio of the Balance of Payment (as % of service exports) of 2008 in Albania to that in Argentina?
Ensure brevity in your answer.  0.5. What is the ratio of the Balance of Payment (as % of service exports) of 2005 in Albania to that in Armenia?
Your response must be concise. 0.46. What is the ratio of the Balance of Payment (as % of service exports) in 2006 in Albania to that in Armenia?
Keep it short and to the point. 0.57. What is the ratio of the Balance of Payment (as % of service exports) of 2007 in Albania to that in Armenia?
Make the answer very short. 0.43. What is the ratio of the Balance of Payment (as % of service exports) of 2008 in Albania to that in Armenia?
Your answer should be very brief. 0.49. What is the ratio of the Balance of Payment (as % of service exports) in 2005 in Argentina to that in Armenia?
Make the answer very short. 0.93. What is the ratio of the Balance of Payment (as % of service exports) of 2006 in Argentina to that in Armenia?
Provide a short and direct response. 1.08. What is the ratio of the Balance of Payment (as % of service exports) of 2008 in Argentina to that in Armenia?
Provide a succinct answer. 0.97. What is the difference between the highest and the second highest Balance of Payment (as % of service exports) of 2005?
Provide a short and direct response. 0.62. What is the difference between the highest and the second highest Balance of Payment (as % of service exports) of 2006?
Ensure brevity in your answer.  0.95. What is the difference between the highest and the second highest Balance of Payment (as % of service exports) of 2007?
Provide a succinct answer. 0.94. What is the difference between the highest and the second highest Balance of Payment (as % of service exports) of 2008?
Keep it short and to the point. 0.96. What is the difference between the highest and the lowest Balance of Payment (as % of service exports) in 2005?
Keep it short and to the point. 11.73. What is the difference between the highest and the lowest Balance of Payment (as % of service exports) of 2006?
Offer a very short reply. 10.72. What is the difference between the highest and the lowest Balance of Payment (as % of service exports) in 2007?
Offer a terse response. 13.26. What is the difference between the highest and the lowest Balance of Payment (as % of service exports) in 2008?
Provide a succinct answer. 13.68. 